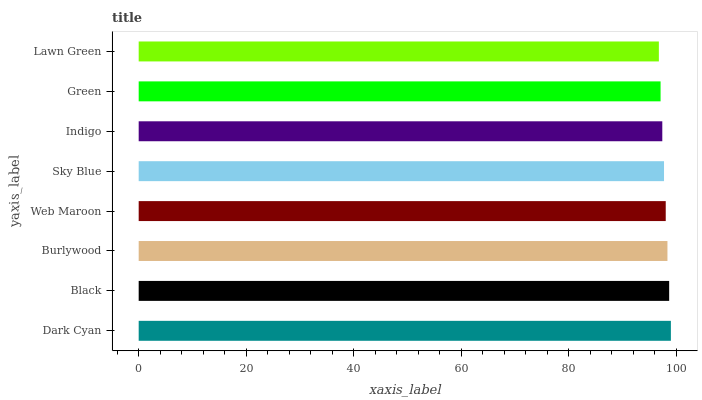Is Lawn Green the minimum?
Answer yes or no. Yes. Is Dark Cyan the maximum?
Answer yes or no. Yes. Is Black the minimum?
Answer yes or no. No. Is Black the maximum?
Answer yes or no. No. Is Dark Cyan greater than Black?
Answer yes or no. Yes. Is Black less than Dark Cyan?
Answer yes or no. Yes. Is Black greater than Dark Cyan?
Answer yes or no. No. Is Dark Cyan less than Black?
Answer yes or no. No. Is Web Maroon the high median?
Answer yes or no. Yes. Is Sky Blue the low median?
Answer yes or no. Yes. Is Lawn Green the high median?
Answer yes or no. No. Is Lawn Green the low median?
Answer yes or no. No. 